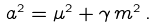Convert formula to latex. <formula><loc_0><loc_0><loc_500><loc_500>a ^ { 2 } = \mu ^ { 2 } + \gamma \, m ^ { 2 } \, .</formula> 